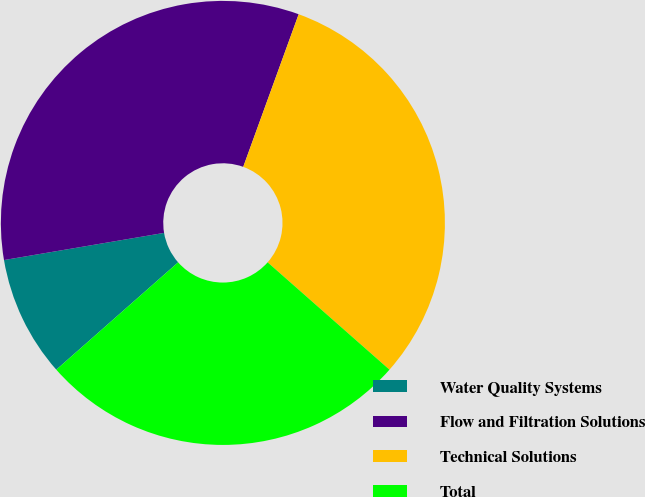Convert chart. <chart><loc_0><loc_0><loc_500><loc_500><pie_chart><fcel>Water Quality Systems<fcel>Flow and Filtration Solutions<fcel>Technical Solutions<fcel>Total<nl><fcel>8.82%<fcel>33.22%<fcel>30.95%<fcel>27.01%<nl></chart> 